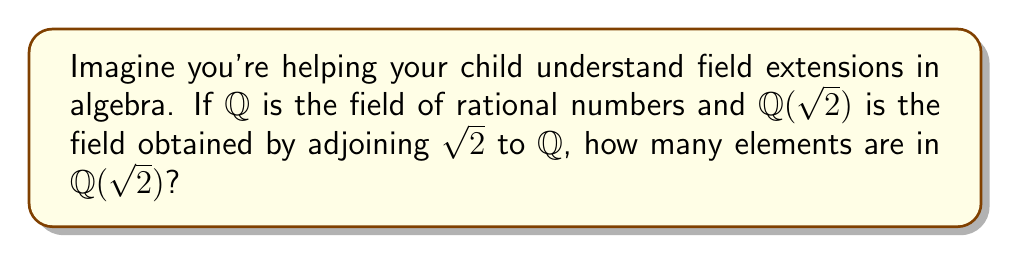Can you answer this question? Let's approach this step-by-step:

1) First, recall that $\mathbb{Q}(\sqrt{2})$ is the smallest field containing both $\mathbb{Q}$ and $\sqrt{2}$.

2) Any element in $\mathbb{Q}(\sqrt{2})$ can be written in the form $a + b\sqrt{2}$, where $a$ and $b$ are rational numbers.

3) This is because:
   - We can add, subtract, multiply, and divide elements of this form and always get another element of the same form.
   - Every element of $\mathbb{Q}$ is included when $b = 0$.
   - $\sqrt{2}$ itself is included when $a = 0$ and $b = 1$.

4) Now, let's consider how many possibilities there are for $a$ and $b$:
   - $a$ can be any rational number
   - $b$ can be any rational number

5) The set of rational numbers is infinite (there are infinitely many fractions).

6) Therefore, there are infinitely many possibilities for both $a$ and $b$.

7) This means there are infinitely many elements in $\mathbb{Q}(\sqrt{2})$.

8) In field theory, we say that $\mathbb{Q}(\sqrt{2})$ has infinite cardinality, or that it's an infinite field extension of $\mathbb{Q}$.
Answer: Infinitely many 